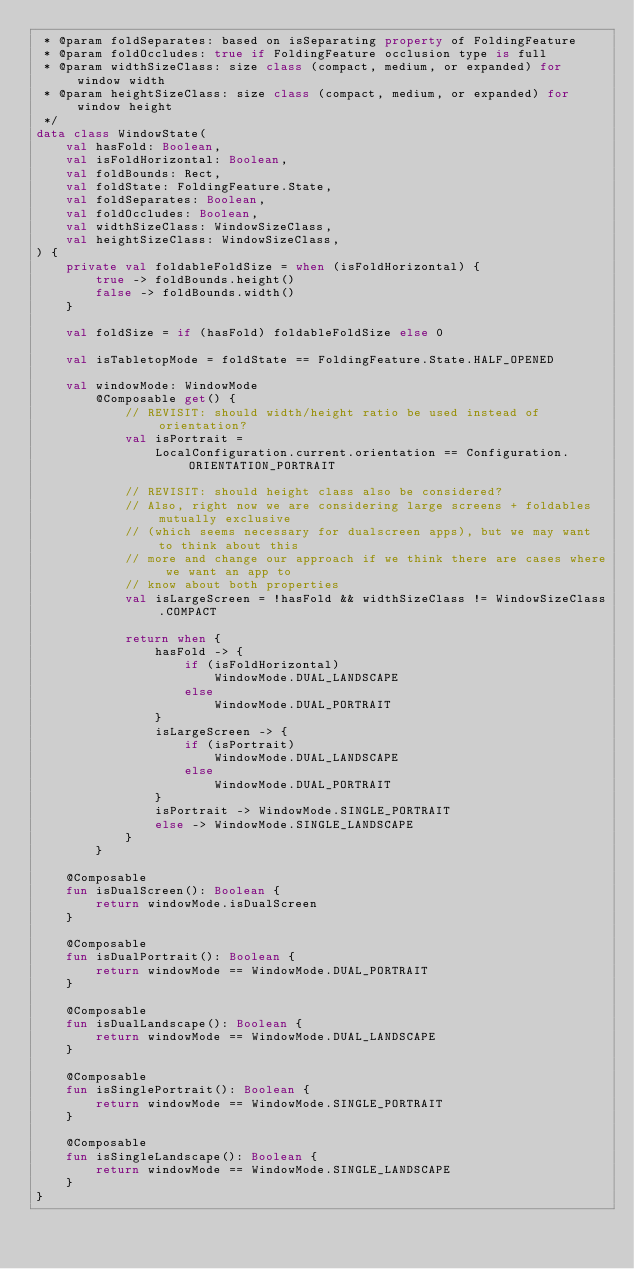<code> <loc_0><loc_0><loc_500><loc_500><_Kotlin_> * @param foldSeparates: based on isSeparating property of FoldingFeature
 * @param foldOccludes: true if FoldingFeature occlusion type is full
 * @param widthSizeClass: size class (compact, medium, or expanded) for window width
 * @param heightSizeClass: size class (compact, medium, or expanded) for window height
 */
data class WindowState(
    val hasFold: Boolean,
    val isFoldHorizontal: Boolean,
    val foldBounds: Rect,
    val foldState: FoldingFeature.State,
    val foldSeparates: Boolean,
    val foldOccludes: Boolean,
    val widthSizeClass: WindowSizeClass,
    val heightSizeClass: WindowSizeClass,
) {
    private val foldableFoldSize = when (isFoldHorizontal) {
        true -> foldBounds.height()
        false -> foldBounds.width()
    }

    val foldSize = if (hasFold) foldableFoldSize else 0

    val isTabletopMode = foldState == FoldingFeature.State.HALF_OPENED

    val windowMode: WindowMode
        @Composable get() {
            // REVISIT: should width/height ratio be used instead of orientation?
            val isPortrait =
                LocalConfiguration.current.orientation == Configuration.ORIENTATION_PORTRAIT

            // REVISIT: should height class also be considered?
            // Also, right now we are considering large screens + foldables mutually exclusive
            // (which seems necessary for dualscreen apps), but we may want to think about this
            // more and change our approach if we think there are cases where we want an app to
            // know about both properties
            val isLargeScreen = !hasFold && widthSizeClass != WindowSizeClass.COMPACT

            return when {
                hasFold -> {
                    if (isFoldHorizontal)
                        WindowMode.DUAL_LANDSCAPE
                    else
                        WindowMode.DUAL_PORTRAIT
                }
                isLargeScreen -> {
                    if (isPortrait)
                        WindowMode.DUAL_LANDSCAPE
                    else
                        WindowMode.DUAL_PORTRAIT
                }
                isPortrait -> WindowMode.SINGLE_PORTRAIT
                else -> WindowMode.SINGLE_LANDSCAPE
            }
        }

    @Composable
    fun isDualScreen(): Boolean {
        return windowMode.isDualScreen
    }

    @Composable
    fun isDualPortrait(): Boolean {
        return windowMode == WindowMode.DUAL_PORTRAIT
    }

    @Composable
    fun isDualLandscape(): Boolean {
        return windowMode == WindowMode.DUAL_LANDSCAPE
    }

    @Composable
    fun isSinglePortrait(): Boolean {
        return windowMode == WindowMode.SINGLE_PORTRAIT
    }

    @Composable
    fun isSingleLandscape(): Boolean {
        return windowMode == WindowMode.SINGLE_LANDSCAPE
    }
}
</code> 